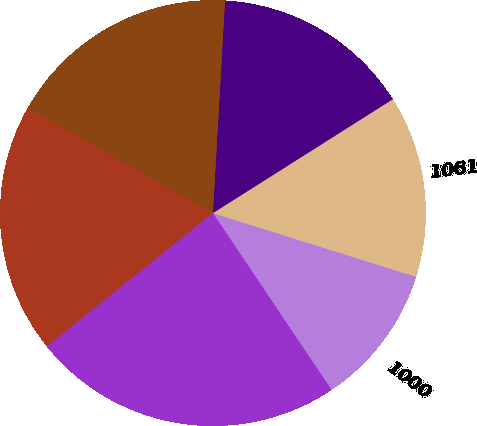<chart> <loc_0><loc_0><loc_500><loc_500><pie_chart><fcel>1000<fcel>1061<fcel>1437<fcel>1524<fcel>1166<fcel>1663<nl><fcel>10.76%<fcel>13.82%<fcel>15.11%<fcel>17.7%<fcel>18.98%<fcel>23.63%<nl></chart> 